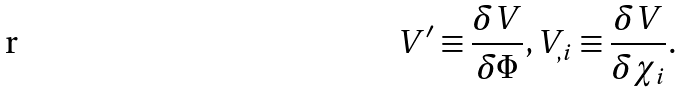<formula> <loc_0><loc_0><loc_500><loc_500>V ^ { \prime } \equiv \frac { \delta V } { \delta \Phi } , V _ { , i } \equiv \frac { \delta V } { \delta \chi _ { i } } .</formula> 